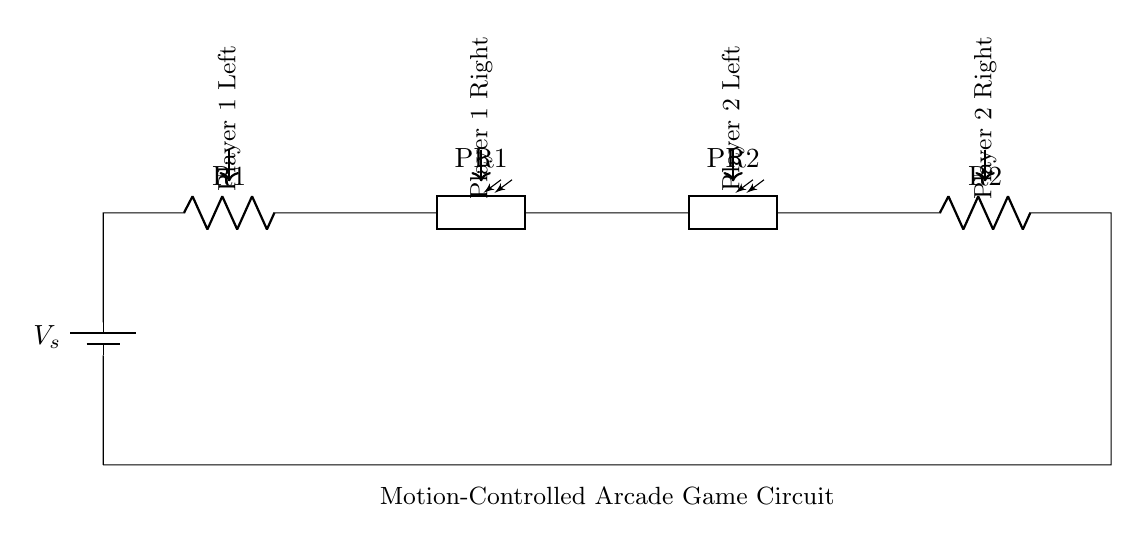What components are in the circuit? The circuit contains a battery, two resistors, and two photoresistors. These components are connected in series and are labeled in the diagram.
Answer: battery, two resistors, two photoresistors What is the role of the photoresistors? The photoresistors change their resistance based on light intensity, which allows them to detect hand movements by measuring varying light conditions caused by the player's hands.
Answer: detect hand movements How many photoresistors are in the circuit? The diagram shows two photoresistors labeled PR1 and PR2. You can count them directly in the circuit representation.
Answer: two What is the direction of current flow in this circuit? The current flows from the battery through the circuit towards the ground. It's typically from the positive terminal of the battery, through the resistors and photoresistors, and back to the negative terminal.
Answer: clockwise If one photoresistor is covered, how is the circuit behavior affected? If one photoresistor is covered, its resistance increases, which affects the current distribution. The overall circuit will see a higher total resistance, potentially resulting in less current flowing through that part of the circuit compared to the other. This could signal a hand movement for that player.
Answer: decreased current in affected branch What type of circuit is represented here? The circuit is a series circuit, as all components are connected end-to-end in a single path for current flow. You can tell because there's only one continuous loop.
Answer: series circuit Which players are represented by the components? Players are represented by the labels near each photoresistor; Player 1 is on the left and right sides of PR1, and Player 2 is on the left and right of PR2. This labeling indicates which side is responsible for detecting movements for each player.
Answer: Player 1 and Player 2 